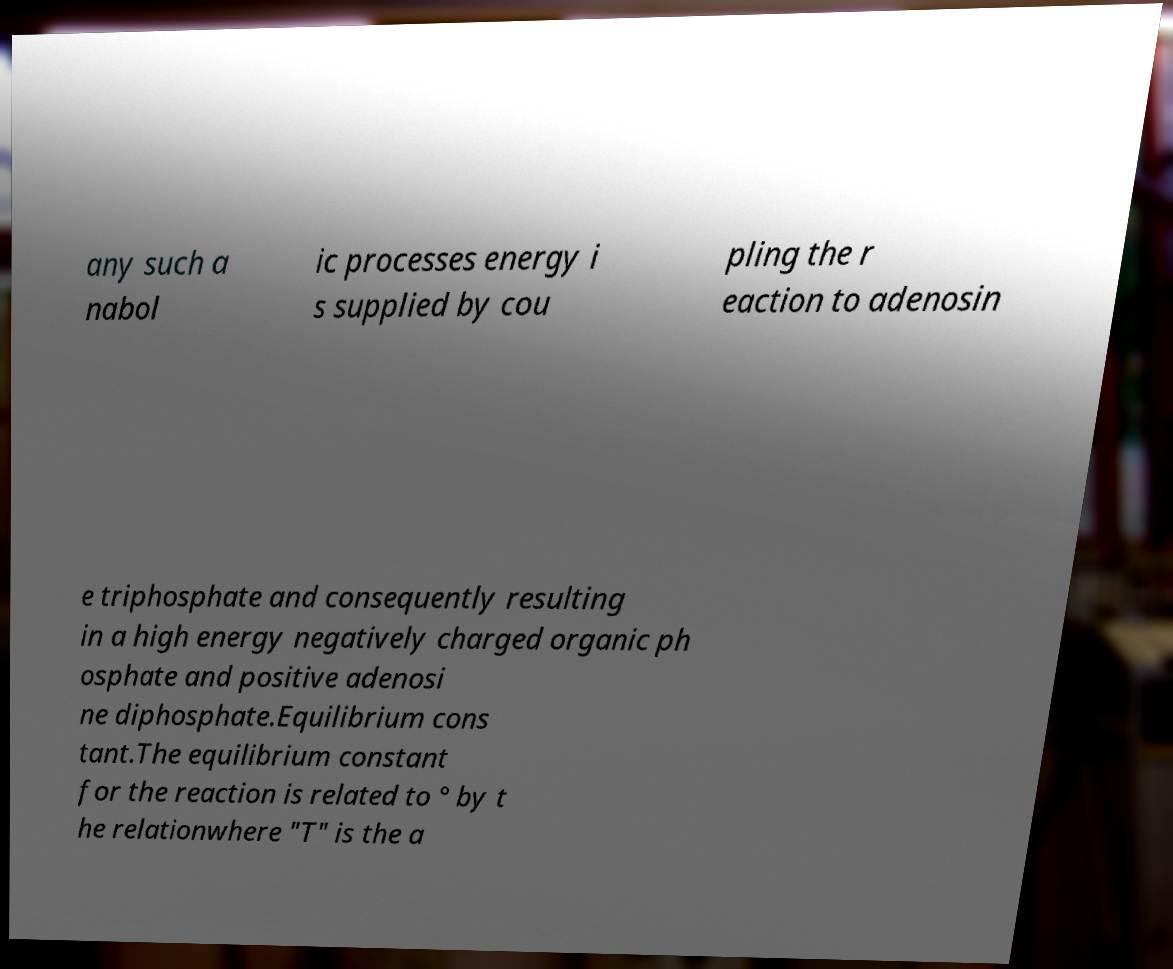I need the written content from this picture converted into text. Can you do that? any such a nabol ic processes energy i s supplied by cou pling the r eaction to adenosin e triphosphate and consequently resulting in a high energy negatively charged organic ph osphate and positive adenosi ne diphosphate.Equilibrium cons tant.The equilibrium constant for the reaction is related to ° by t he relationwhere "T" is the a 